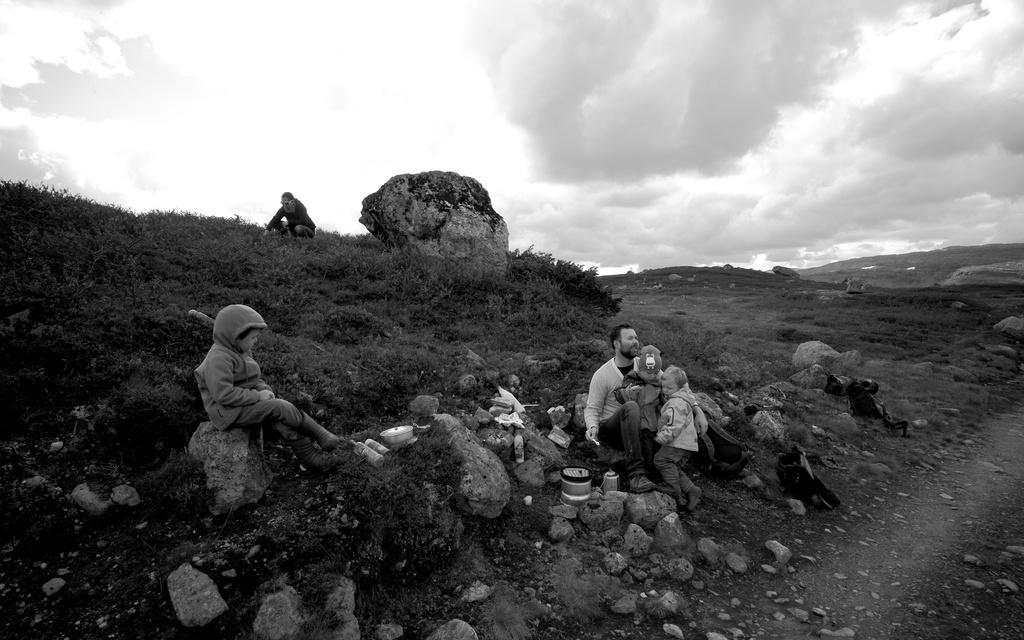Please provide a concise description of this image. On the left side, there is a child sitting on a rock. Beside him, there are bottles, a box and other objects. On the right side, there is a person sitting on a rock, holding a child who is in the mask. Beside this child, there is another child. Beside them, there are bottles and other objects on the ground on a hill, on which there are rocks, bags and plants. Above these persons, there is a person sitting on the grass. In the background, there are mountains and there are clouds in the sky. 